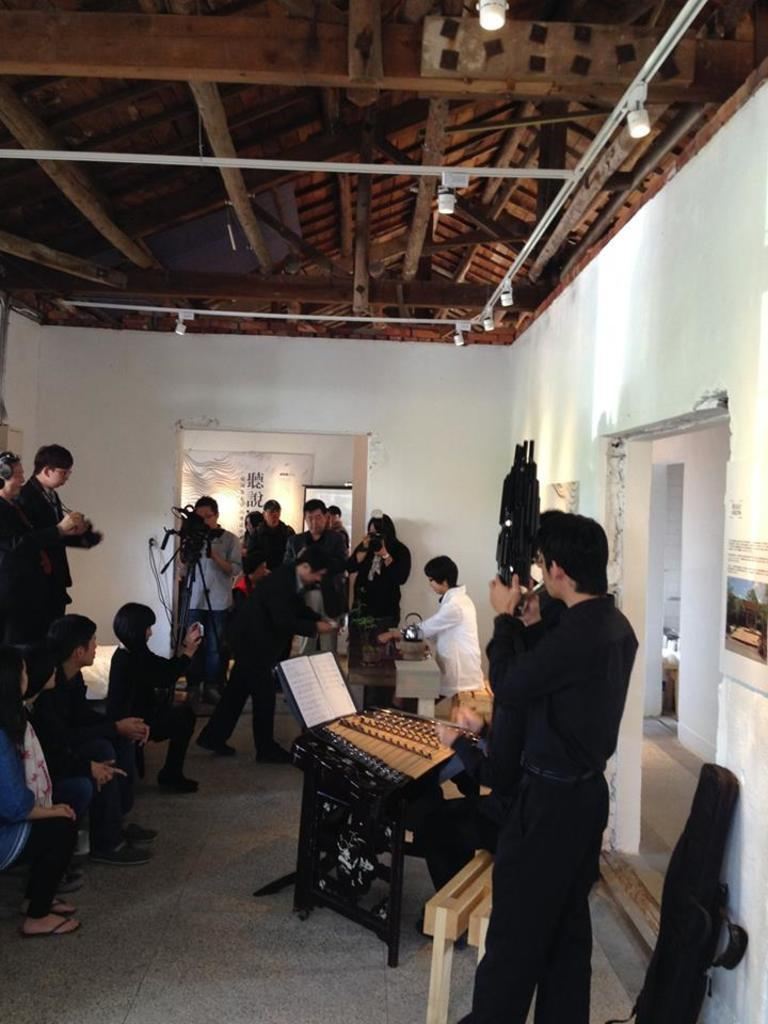What are the people in the image doing? There are people sitting on the left side of the image, and there are people standing in the image. Can you describe the lighting in the image? There are lights attached to the ceiling in the image. What type of advice is the lawyer giving on the sidewalk in the image? There is no lawyer or sidewalk present in the image. 